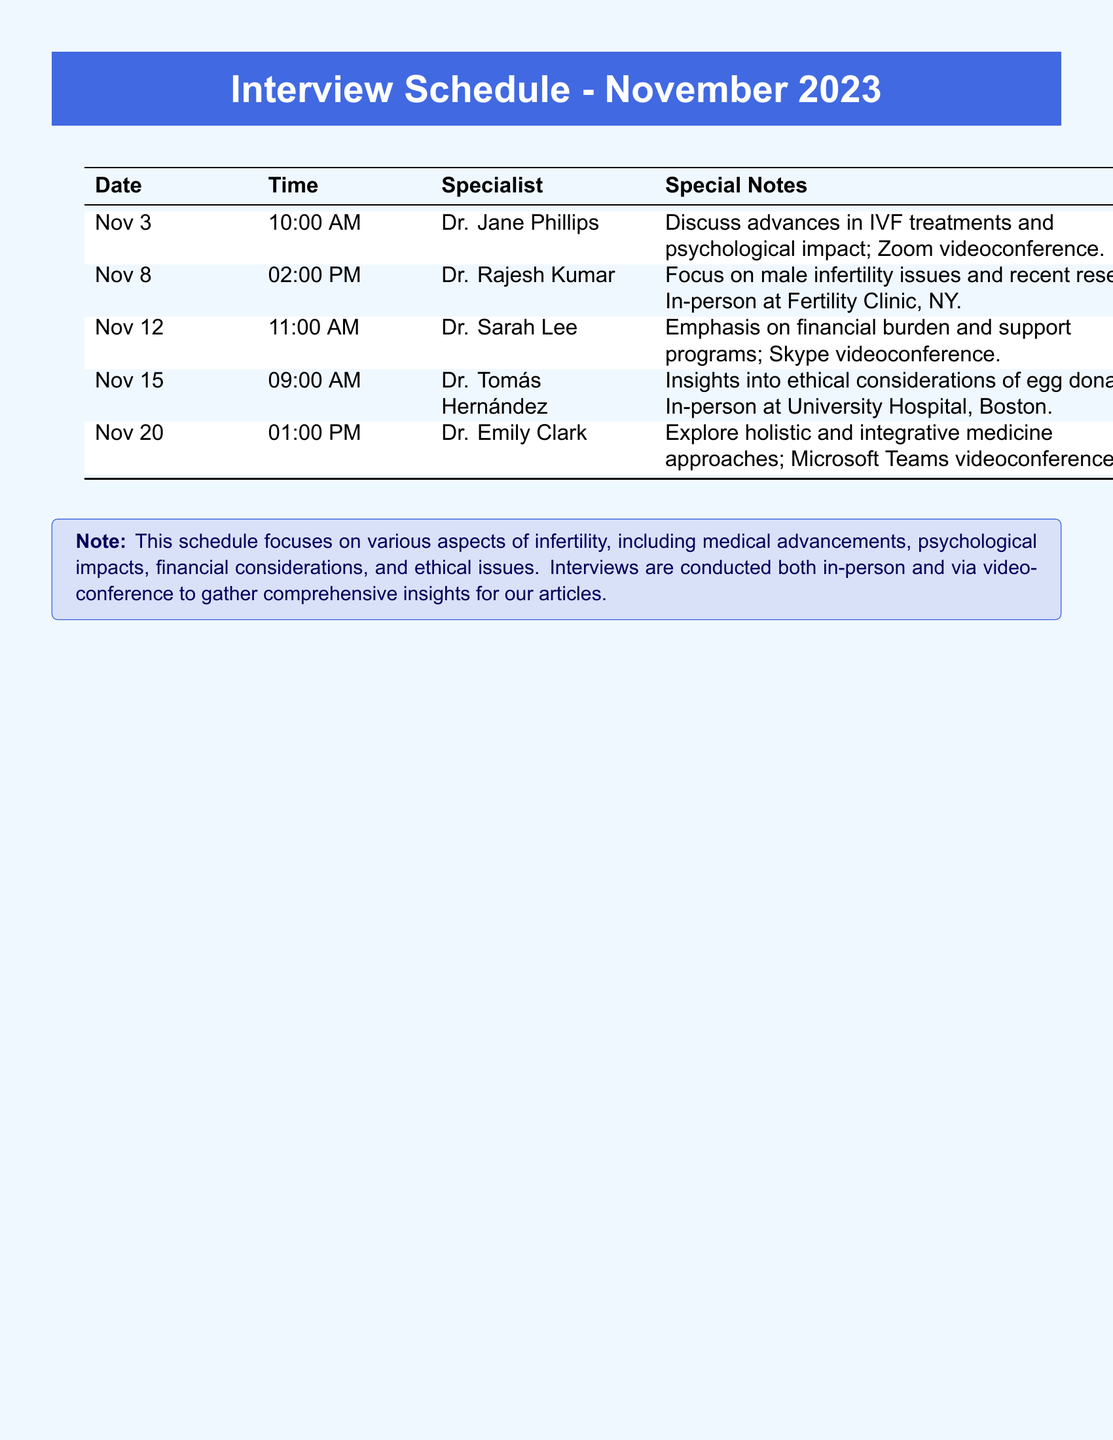What is the date of the first interview? The first interview is scheduled for November 3.
Answer: November 3 Who is the specialist on November 15? The specialist on November 15 is Dr. Tomás Hernández.
Answer: Dr. Tomás Hernández What time is the interview with Dr. Rajesh Kumar? The interview with Dr. Rajesh Kumar is at 02:00 PM.
Answer: 02:00 PM How many interviews are scheduled in total? The document lists five interviews scheduled for November 2023.
Answer: 5 What is the focus of the interview with Dr. Sarah Lee? The focus is on the financial burden and support programs.
Answer: Financial burden and support programs Which interview will be conducted via Microsoft Teams? The interview with Dr. Emily Clark will be conducted via Microsoft Teams.
Answer: Dr. Emily Clark What type of appointment is scheduled with Dr. Jane Phillips? The appointment with Dr. Jane Phillips is a Zoom videoconference.
Answer: Zoom videoconference Which specialist is focusing on male infertility issues? Dr. Rajesh Kumar is focusing on male infertility issues.
Answer: Dr. Rajesh Kumar What does the note at the bottom of the document emphasize? The note emphasizes various aspects of infertility, including medical advancements and psychological impacts.
Answer: Various aspects of infertility 